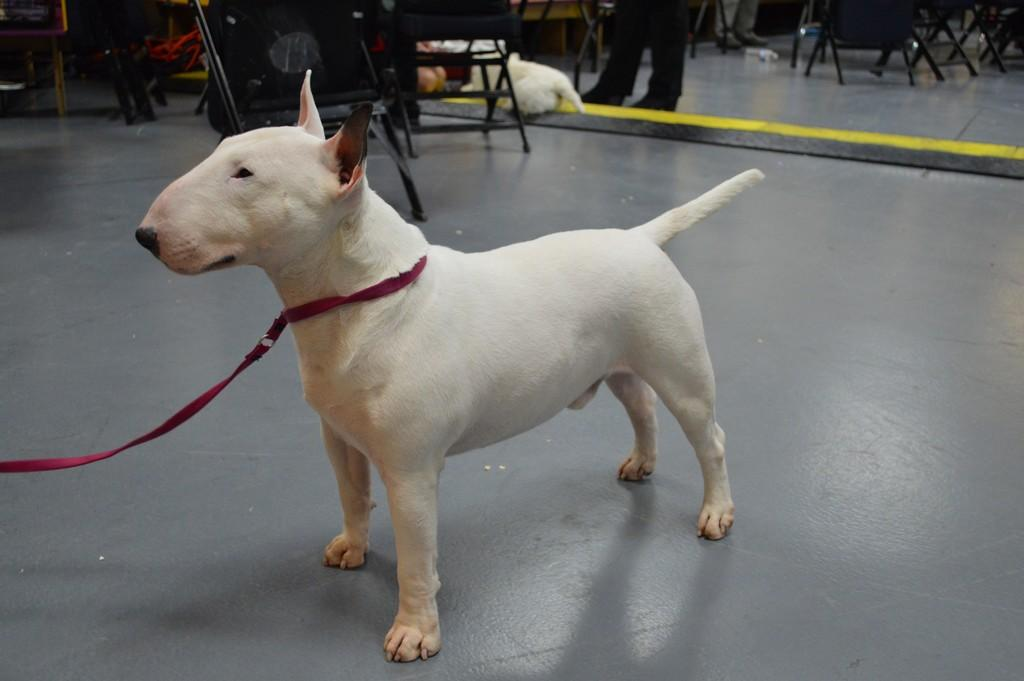Where was the image taken? The image was taken indoors. What is in the foreground of the image? There is an animal in the foreground of the image. What is the animal doing in the image? The animal is standing on the ground. What can be seen in the background of the image? Chairs and at least one person are visible in the background of the image. Are there any other objects or items in the background of the image? Yes, there are other unspecified items in the background of the image. What time does the animal self-destruct in the image? There is no indication of the animal self-destructing or any time-related information in the image. 